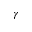Convert formula to latex. <formula><loc_0><loc_0><loc_500><loc_500>\gamma</formula> 